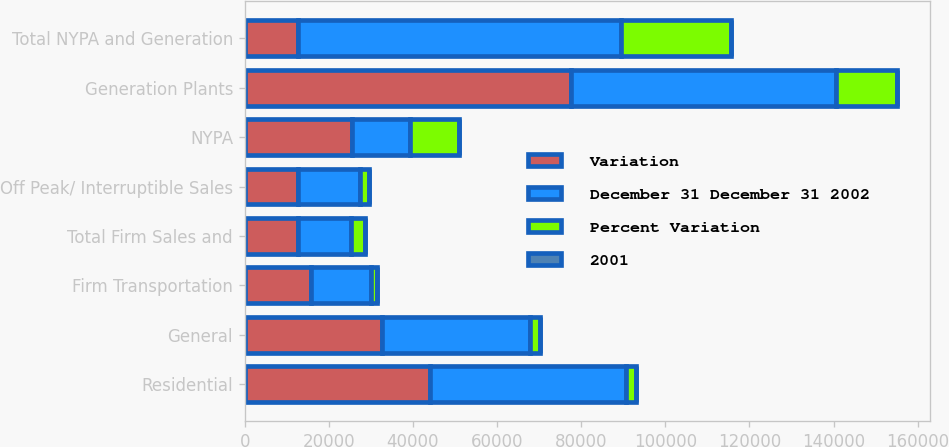<chart> <loc_0><loc_0><loc_500><loc_500><stacked_bar_chart><ecel><fcel>Residential<fcel>General<fcel>Firm Transportation<fcel>Total Firm Sales and<fcel>Off Peak/ Interruptible Sales<fcel>NYPA<fcel>Generation Plants<fcel>Total NYPA and Generation<nl><fcel>Variation<fcel>44163<fcel>32682<fcel>15695<fcel>12622<fcel>12622<fcel>25467<fcel>77516<fcel>12622<nl><fcel>December 31 December 31 2002<fcel>46506<fcel>35118<fcel>14280<fcel>12622<fcel>14731<fcel>13762<fcel>62991<fcel>76753<nl><fcel>Percent Variation<fcel>2343<fcel>2436<fcel>1415<fcel>3364<fcel>2109<fcel>11705<fcel>14525<fcel>26230<nl><fcel>2001<fcel>5<fcel>6.9<fcel>9.9<fcel>3.5<fcel>14.3<fcel>85.1<fcel>23.1<fcel>34.2<nl></chart> 